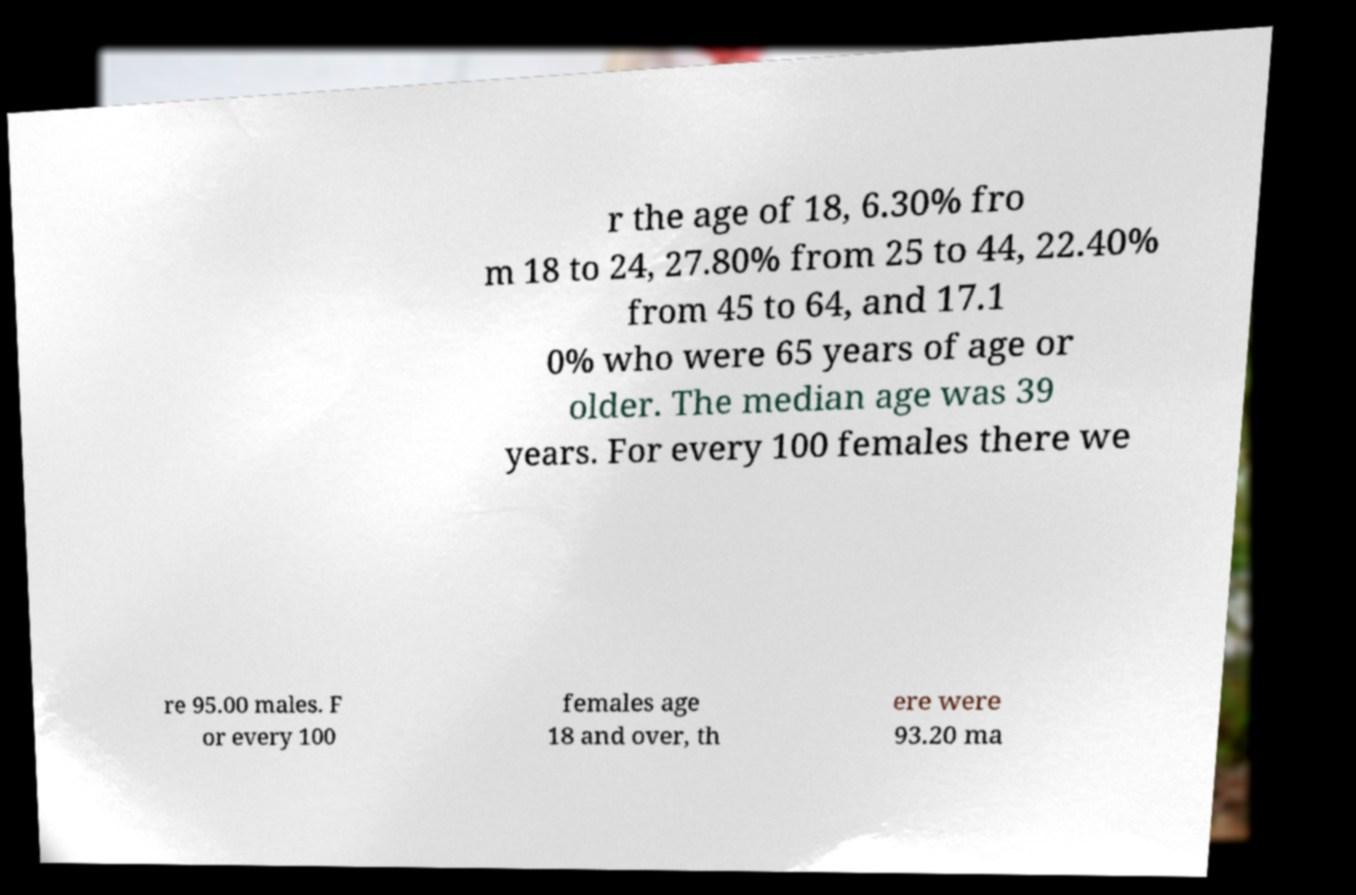Can you accurately transcribe the text from the provided image for me? r the age of 18, 6.30% fro m 18 to 24, 27.80% from 25 to 44, 22.40% from 45 to 64, and 17.1 0% who were 65 years of age or older. The median age was 39 years. For every 100 females there we re 95.00 males. F or every 100 females age 18 and over, th ere were 93.20 ma 